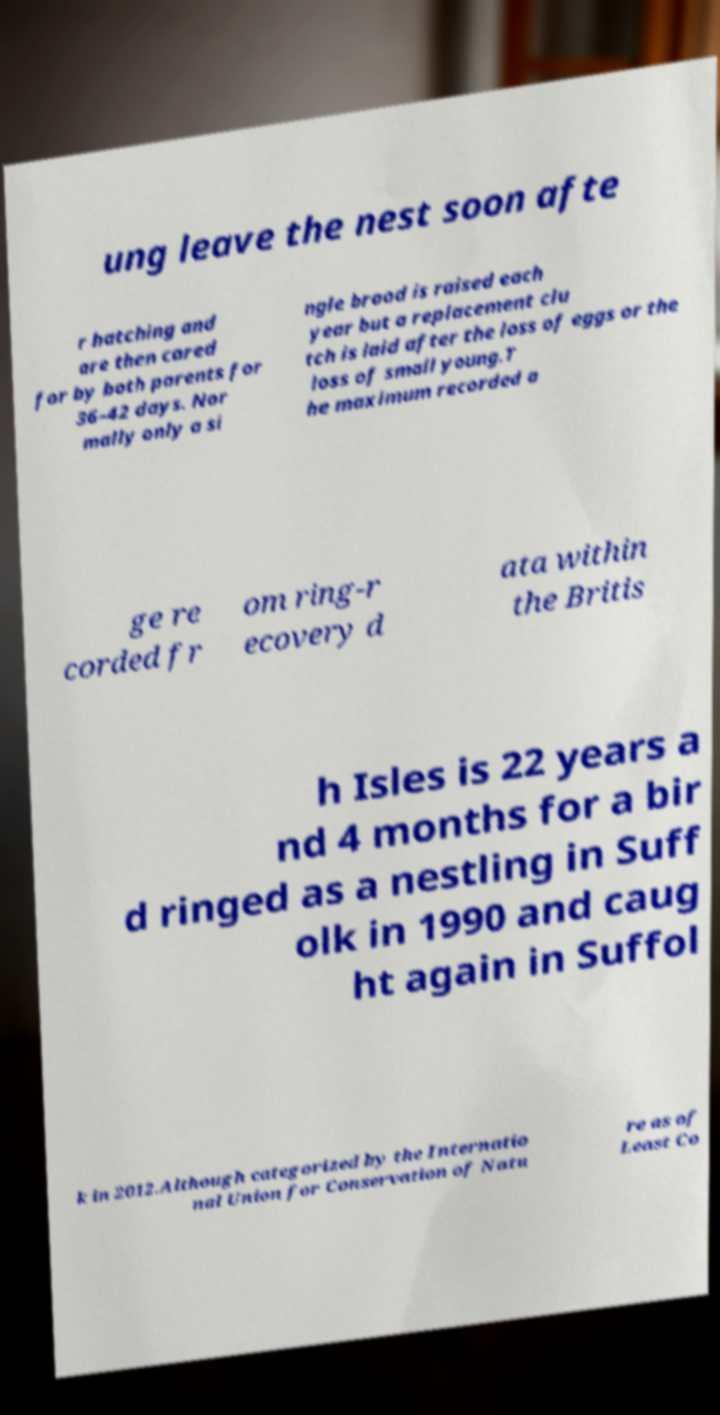Could you extract and type out the text from this image? ung leave the nest soon afte r hatching and are then cared for by both parents for 36–42 days. Nor mally only a si ngle brood is raised each year but a replacement clu tch is laid after the loss of eggs or the loss of small young.T he maximum recorded a ge re corded fr om ring-r ecovery d ata within the Britis h Isles is 22 years a nd 4 months for a bir d ringed as a nestling in Suff olk in 1990 and caug ht again in Suffol k in 2012.Although categorized by the Internatio nal Union for Conservation of Natu re as of Least Co 